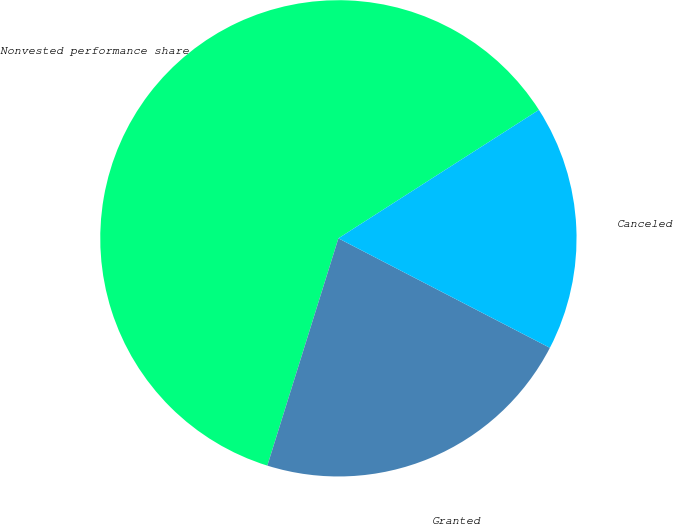<chart> <loc_0><loc_0><loc_500><loc_500><pie_chart><fcel>Nonvested performance share<fcel>Granted<fcel>Canceled<nl><fcel>61.11%<fcel>22.22%<fcel>16.67%<nl></chart> 